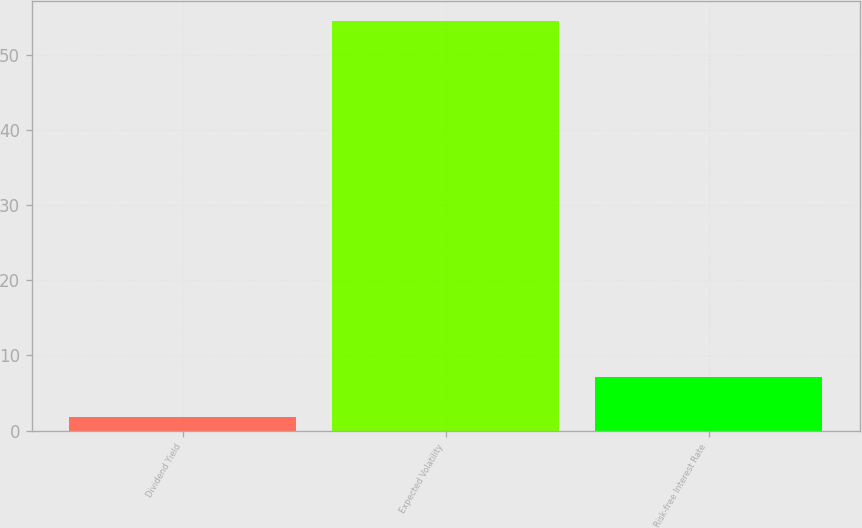Convert chart to OTSL. <chart><loc_0><loc_0><loc_500><loc_500><bar_chart><fcel>Dividend Yield<fcel>Expected Volatility<fcel>Risk-free Interest Rate<nl><fcel>1.81<fcel>54.44<fcel>7.07<nl></chart> 